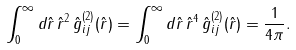<formula> <loc_0><loc_0><loc_500><loc_500>\int _ { 0 } ^ { \infty } d \hat { r } \, \hat { r } ^ { 2 } \, \hat { g } ^ { ( 2 ) } _ { i j } ( \hat { r } ) = \int _ { 0 } ^ { \infty } d \hat { r } \, \hat { r } ^ { 4 } \, \hat { g } ^ { ( 2 ) } _ { i j } ( \hat { r } ) = \frac { 1 } { 4 \pi } .</formula> 